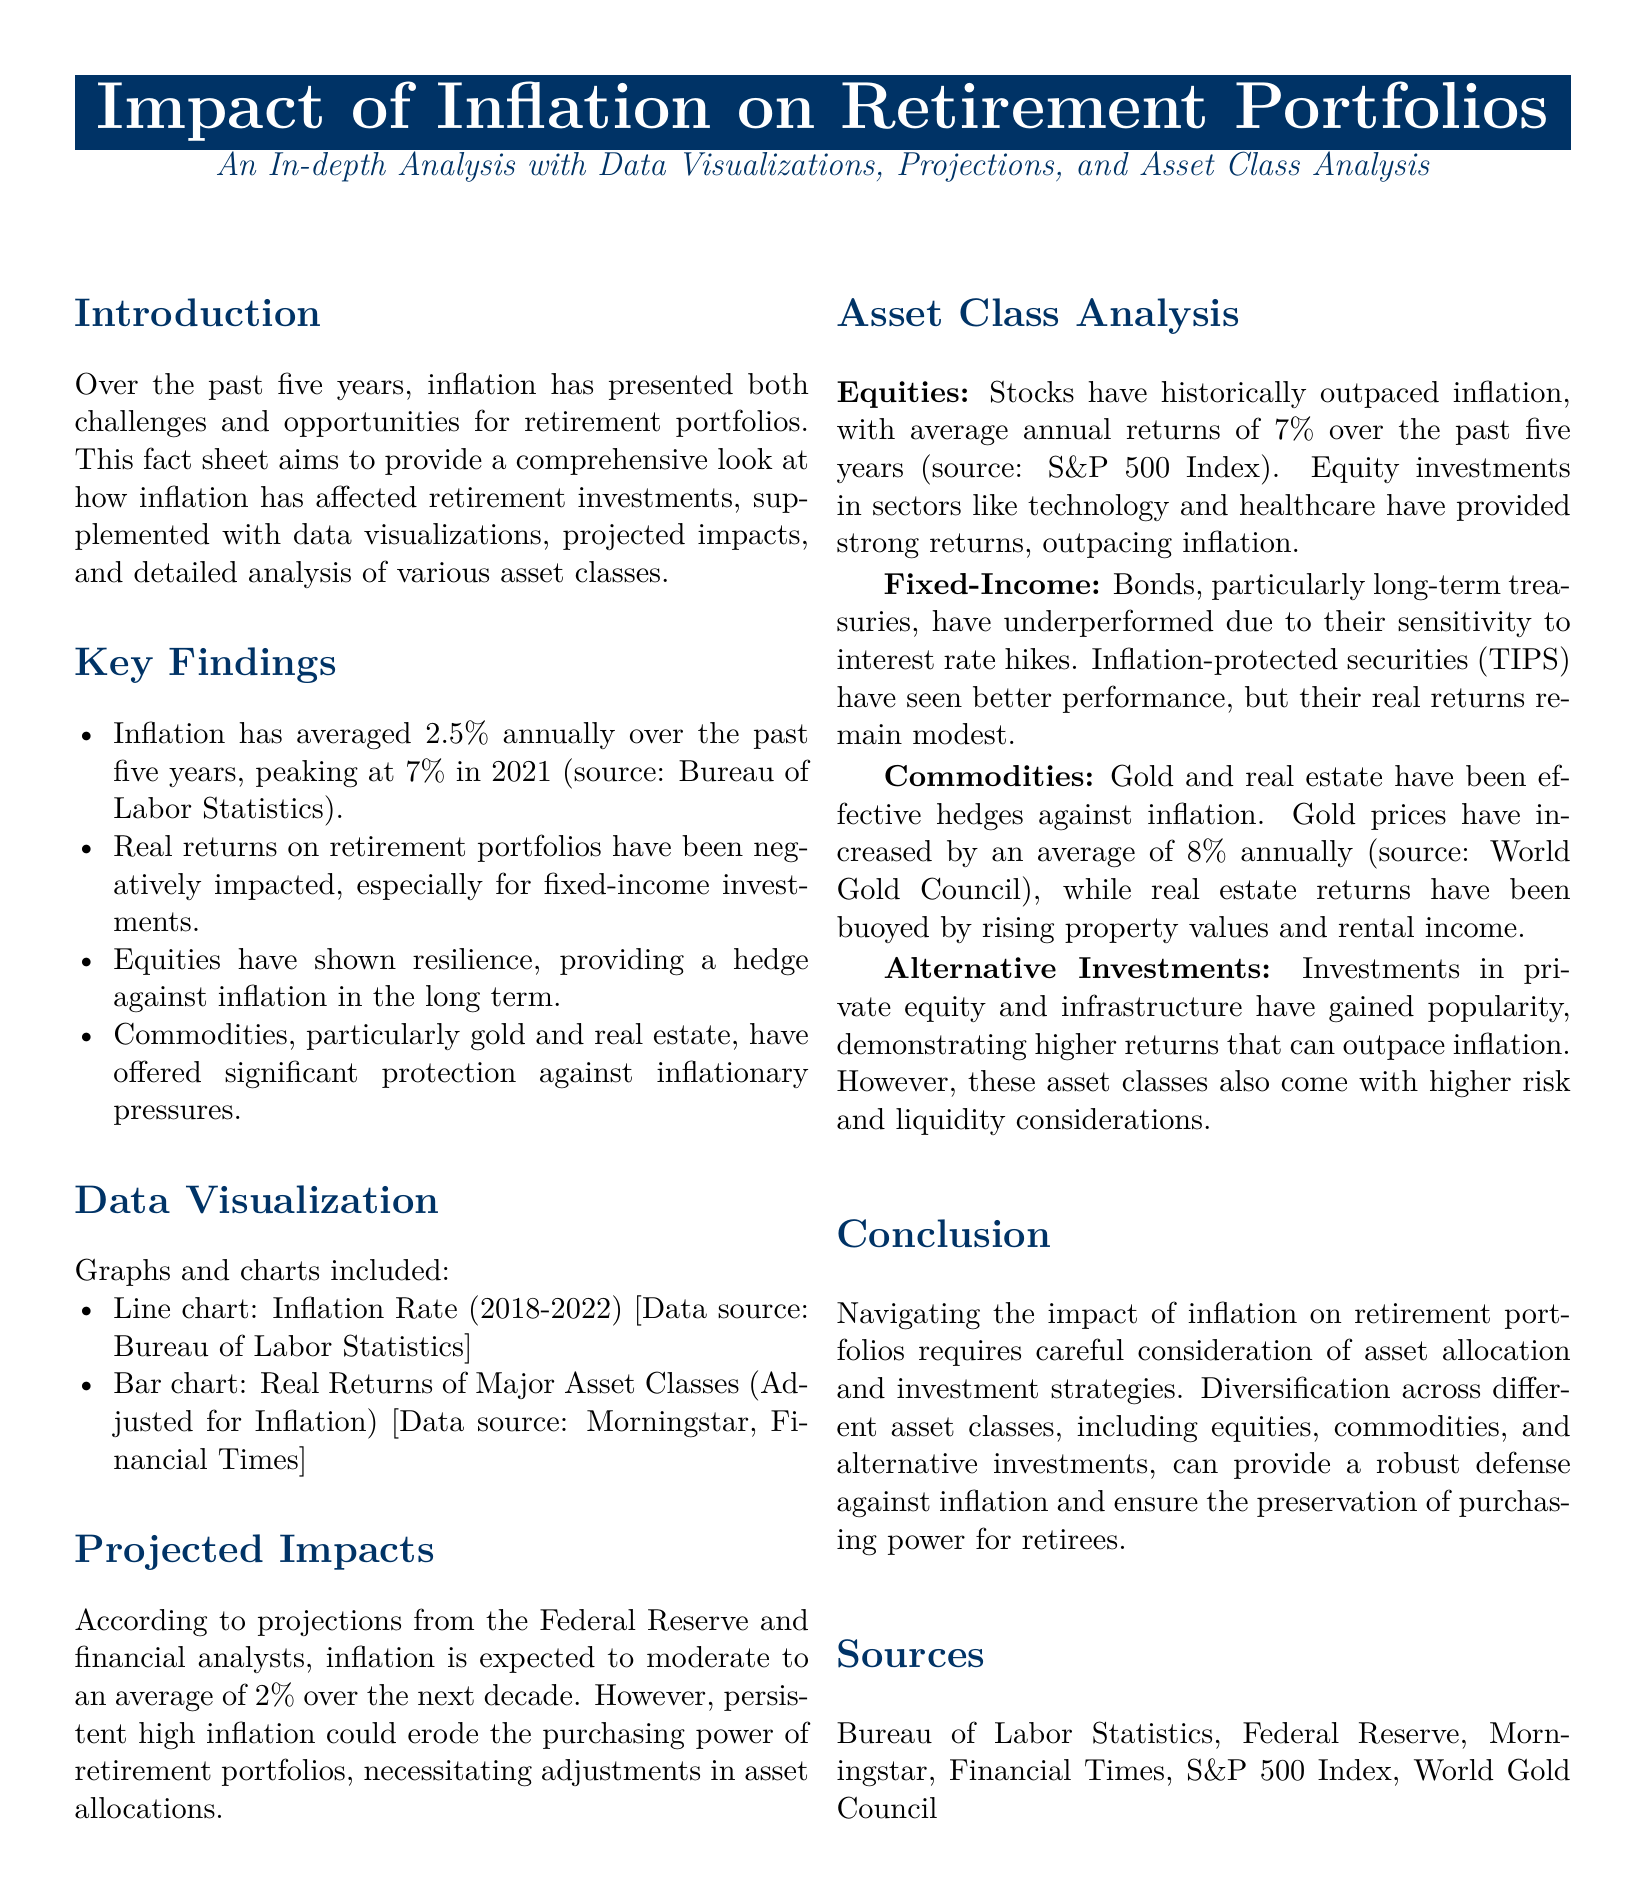What was the average annual inflation rate over the past five years? The average annual inflation rate is provided in the document, which states it has averaged 2.5%.
Answer: 2.5% What was the peak inflation rate in 2021? The document specifies that inflation peaked at 7% in 2021.
Answer: 7% Which asset class has historically outpaced inflation? The document mentions that equities have historically outpaced inflation, specifically referring to stocks.
Answer: Equities What is the average annual return of equities over the past five years? The document notes that stocks have recorded average annual returns of 7% over the last five years.
Answer: 7% Which commodities have offered protection against inflation? The document highlights that gold and real estate have provided significant protection against inflationary pressures.
Answer: Gold and real estate What does TIPS stand for? While not stated directly, it’s reasonable to expect that TIPS refers to Treasury Inflation-Protected Securities, which are mentioned in context.
Answer: TIPS According to projections, what is the expected average inflation rate over the next decade? The projected average inflation rate mentioned in the document is expected to moderate to 2% over the next decade.
Answer: 2% Which sector investments have outpaced inflation in the context of equities? The document indicates that equity investments in sectors like technology and healthcare have outperformed inflation.
Answer: Technology and healthcare What is the consequence of persistent high inflation mentioned in the document? The document states that persistent high inflation could erode the purchasing power of retirement portfolios.
Answer: Erode purchasing power 